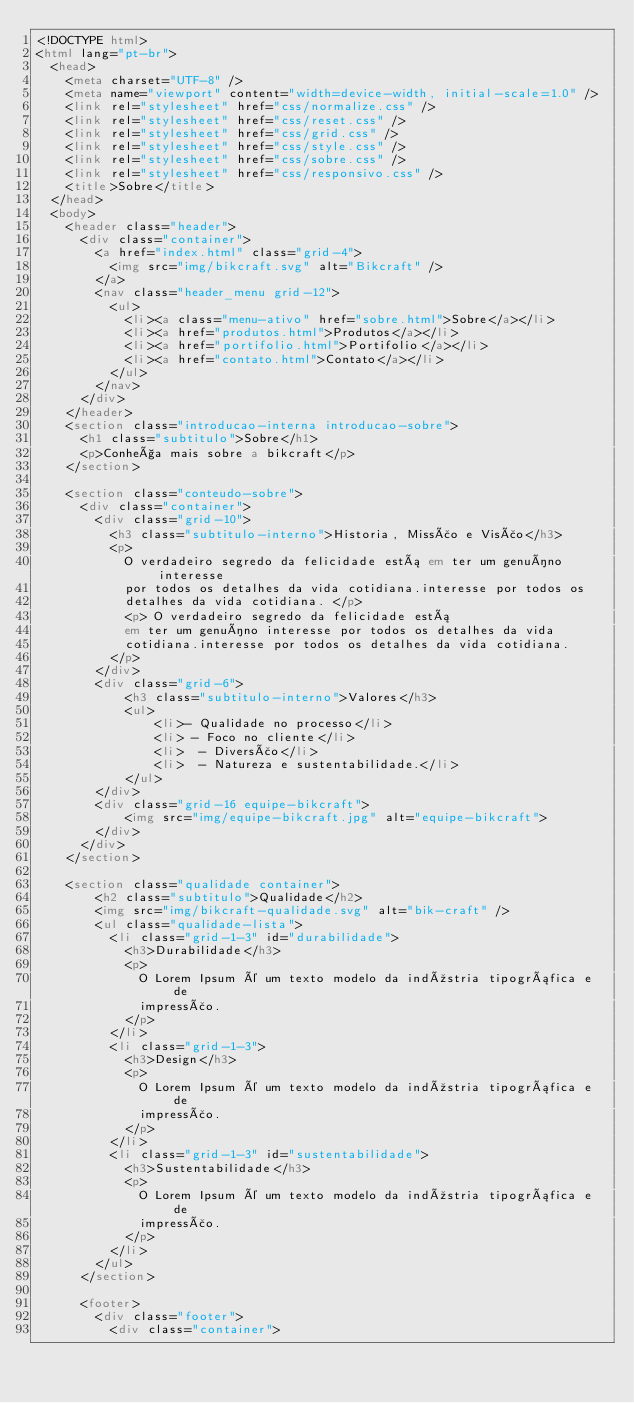<code> <loc_0><loc_0><loc_500><loc_500><_HTML_><!DOCTYPE html>
<html lang="pt-br">
  <head>
    <meta charset="UTF-8" />
    <meta name="viewport" content="width=device-width, initial-scale=1.0" />
    <link rel="stylesheet" href="css/normalize.css" />
    <link rel="stylesheet" href="css/reset.css" />
    <link rel="stylesheet" href="css/grid.css" />
    <link rel="stylesheet" href="css/style.css" />
    <link rel="stylesheet" href="css/sobre.css" />
    <link rel="stylesheet" href="css/responsivo.css" />
    <title>Sobre</title>
  </head>
  <body>
    <header class="header">
      <div class="container">
        <a href="index.html" class="grid-4">
          <img src="img/bikcraft.svg" alt="Bikcraft" />
        </a>
        <nav class="header_menu grid-12">
          <ul>
            <li><a class="menu-ativo" href="sobre.html">Sobre</a></li>
            <li><a href="produtos.html">Produtos</a></li>
            <li><a href="portifolio.html">Portifolio</a></li>
            <li><a href="contato.html">Contato</a></li>
          </ul>
        </nav>
      </div>
    </header>
    <section class="introducao-interna introducao-sobre">
      <h1 class="subtitulo">Sobre</h1>
      <p>Conheça mais sobre a bikcraft</p>
    </section>

    <section class="conteudo-sobre">
      <div class="container">
        <div class="grid-10">
          <h3 class="subtitulo-interno">Historia, Missão e Visão</h3>
          <p>
            O verdadeiro segredo da felicidade está em ter um genuíno interesse
            por todos os detalhes da vida cotidiana.interesse por todos os
            detalhes da vida cotidiana. </p> 
            <p> O verdadeiro segredo da felicidade está
            em ter um genuíno interesse por todos os detalhes da vida
            cotidiana.interesse por todos os detalhes da vida cotidiana.
          </p>
        </div>
        <div class="grid-6">
            <h3 class="subtitulo-interno">Valores</h3>
            <ul>
                <li>- Qualidade no processo</li>
                <li> - Foco no cliente</li>
                <li>  - Diversão</li>
                <li>  - Natureza e sustentabilidade.</li>
            </ul>
        </div>
        <div class="grid-16 equipe-bikcraft">
            <img src="img/equipe-bikcraft.jpg" alt="equipe-bikcraft">
        </div>
      </div>
    </section>

    <section class="qualidade container">
        <h2 class="subtitulo">Qualidade</h2>
        <img src="img/bikcraft-qualidade.svg" alt="bik-craft" />
        <ul class="qualidade-lista">
          <li class="grid-1-3" id="durabilidade">
            <h3>Durabilidade</h3>
            <p>
              O Lorem Ipsum é um texto modelo da indústria tipográfica e de
              impressão.
            </p>
          </li>
          <li class="grid-1-3">
            <h3>Design</h3>
            <p>
              O Lorem Ipsum é um texto modelo da indústria tipográfica e de
              impressão.
            </p>
          </li>
          <li class="grid-1-3" id="sustentabilidade">
            <h3>Sustentabilidade</h3>
            <p>
              O Lorem Ipsum é um texto modelo da indústria tipográfica e de
              impressão.
            </p>
          </li>
        </ul>
      </section>
      
      <footer>
        <div class="footer">
          <div class="container"></code> 